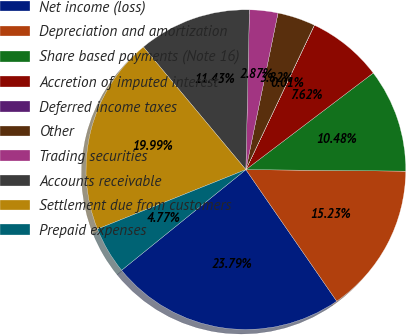Convert chart. <chart><loc_0><loc_0><loc_500><loc_500><pie_chart><fcel>Net income (loss)<fcel>Depreciation and amortization<fcel>Share based payments (Note 16)<fcel>Accretion of imputed interest<fcel>Deferred income taxes<fcel>Other<fcel>Trading securities<fcel>Accounts receivable<fcel>Settlement due from customers<fcel>Prepaid expenses<nl><fcel>23.79%<fcel>15.23%<fcel>10.48%<fcel>7.62%<fcel>0.01%<fcel>3.82%<fcel>2.87%<fcel>11.43%<fcel>19.99%<fcel>4.77%<nl></chart> 